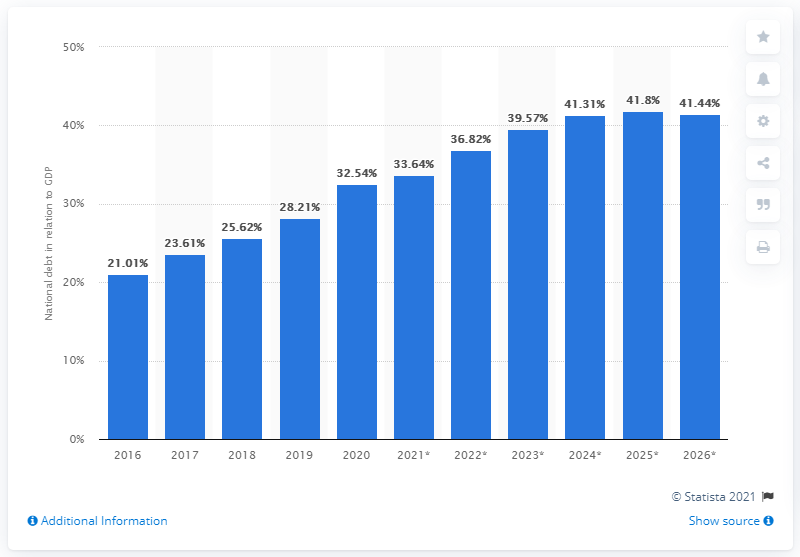What can you infer about Chile's economic situation based on this graph? The graph suggests that Chile's national debt has been increasing as a share of GDP, which could imply that the country is borrowing more in relation to the size of its economy. This could be due to factors like increased government spending, investment in large-scale projects, or efforts to stimulate the economy. A rising debt-to-GDP ratio could raise concerns about the country's long-term debt sustainability if the trend continues. 